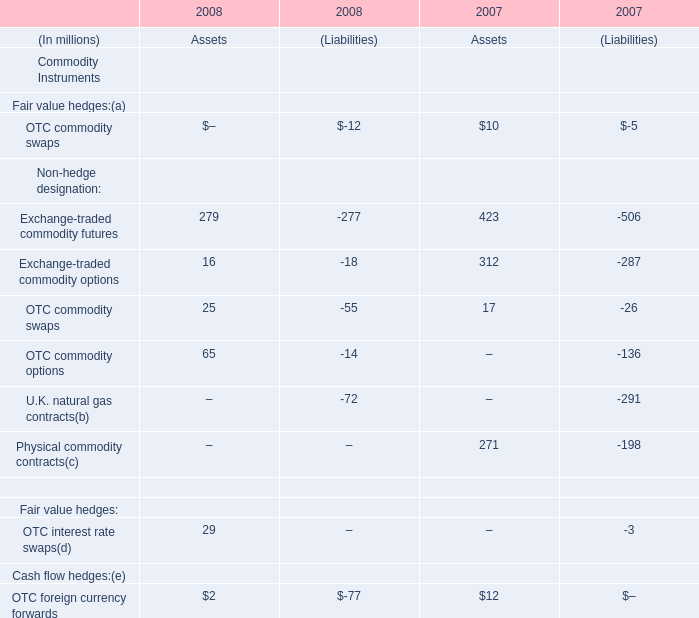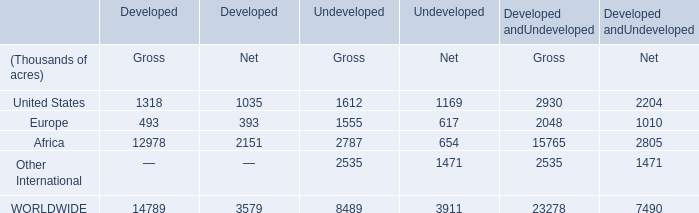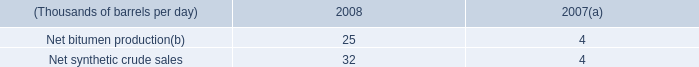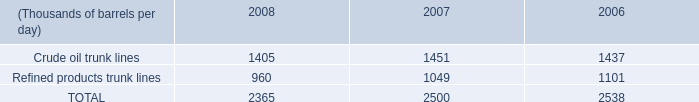what's the total amount of Crude oil trunk lines of 2007, and Europe of Undeveloped Gross ? 
Computations: (1451.0 + 1555.0)
Answer: 3006.0. 